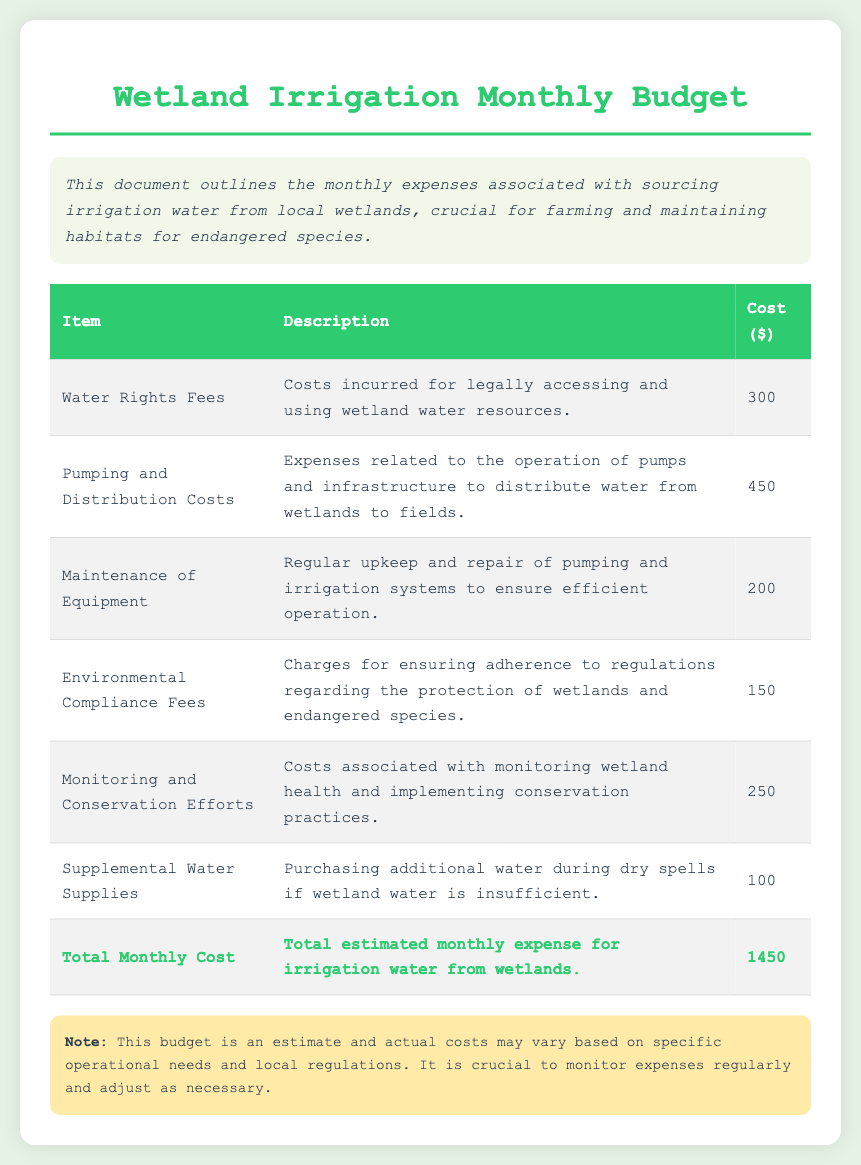What are water rights fees? Water rights fees are costs incurred for legally accessing and using wetland water resources.
Answer: Costs incurred for legally accessing and using wetland water resources What is the cost for pumping and distribution? The cost for pumping and distribution is listed in the table under that category.
Answer: 450 What is the total monthly cost? The total monthly cost is the sum of all the expenses detailed in the budget document.
Answer: 1450 What are the environmental compliance fees? Environmental compliance fees refer to charges for ensuring adherence to regulations regarding the protection of wetlands and endangered species.
Answer: Charges for ensuring adherence to regulations regarding the protection of wetlands and endangered species How much is spent on monitoring and conservation efforts? The budget lists a specific amount allocated to monitoring and conservation efforts as shown in the relevant row of the table.
Answer: 250 What is the purpose of supplemental water supplies? Supplemental water supplies are for purchasing additional water during dry spells if wetland water is insufficient.
Answer: Purchasing additional water during dry spells if wetland water is insufficient How much is allocated for maintenance of equipment? The maintenance of equipment cost is provided in the expense table of the document.
Answer: 200 What is included in the introduction section? The introduction section provides a brief overview of the budgeting document's purpose and importance for farming and habitats.
Answer: Overview of monthly expenses associated with sourcing irrigation water from wetlands 